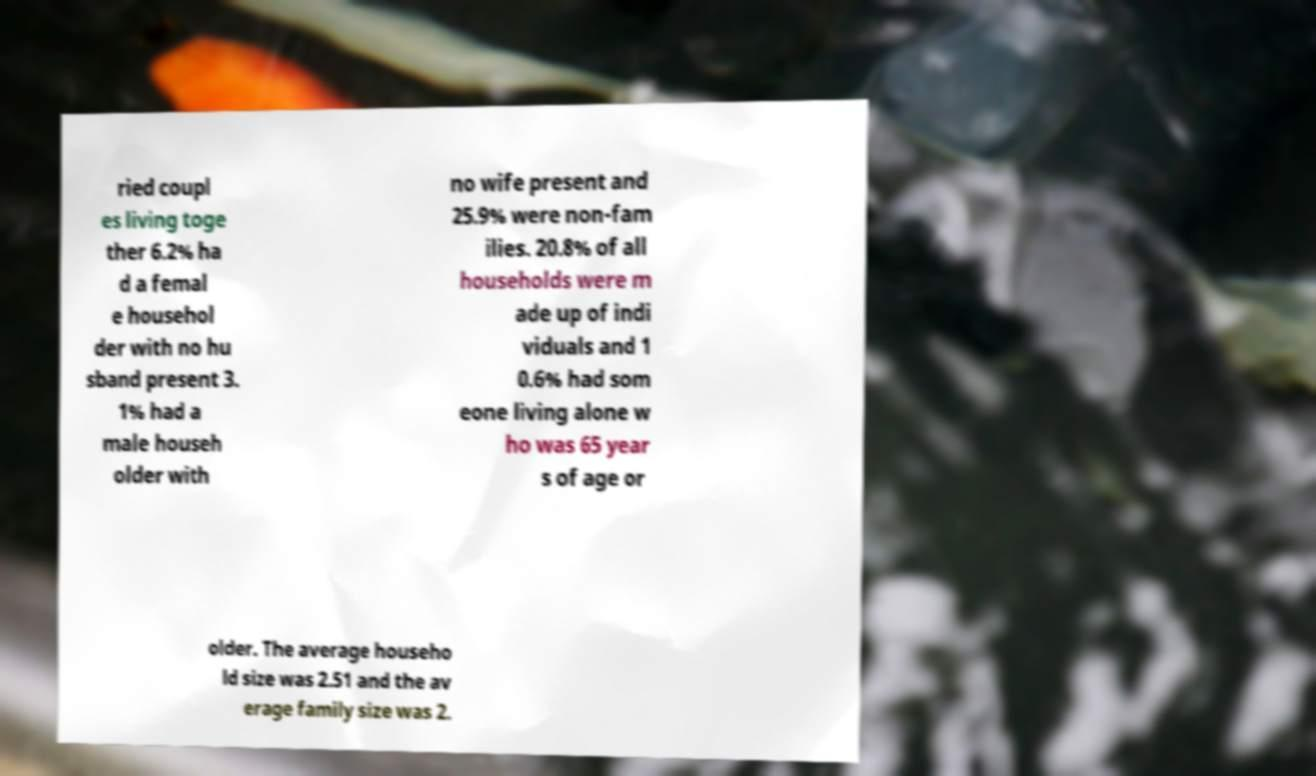Please identify and transcribe the text found in this image. ried coupl es living toge ther 6.2% ha d a femal e househol der with no hu sband present 3. 1% had a male househ older with no wife present and 25.9% were non-fam ilies. 20.8% of all households were m ade up of indi viduals and 1 0.6% had som eone living alone w ho was 65 year s of age or older. The average househo ld size was 2.51 and the av erage family size was 2. 